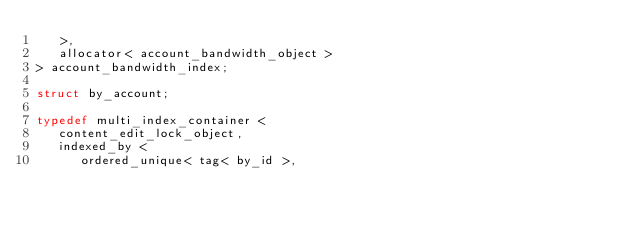Convert code to text. <code><loc_0><loc_0><loc_500><loc_500><_C++_>   >,
   allocator< account_bandwidth_object >
> account_bandwidth_index;

struct by_account;

typedef multi_index_container <
   content_edit_lock_object,
   indexed_by <
      ordered_unique< tag< by_id >,</code> 